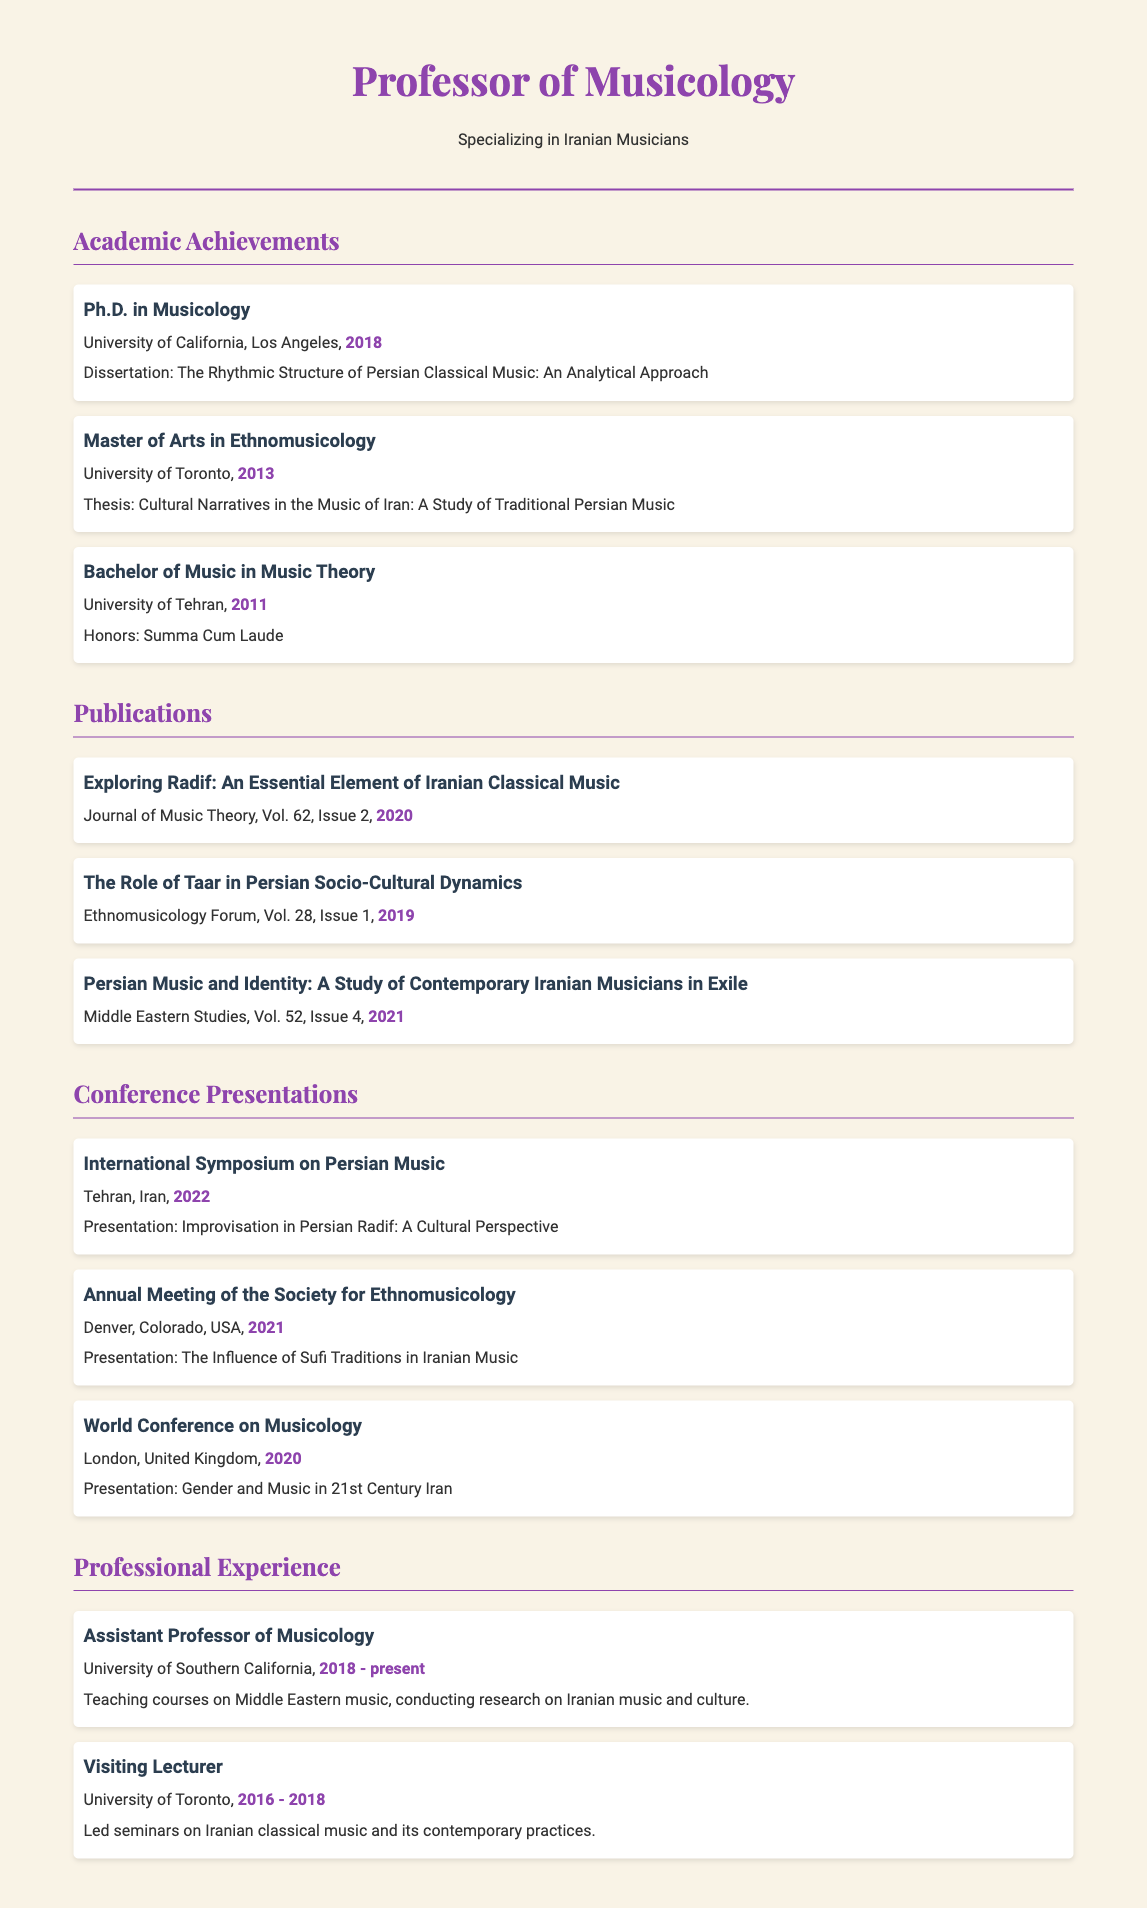What degree did the professor earn in 2018? The document states that the professor earned a Ph.D. in Musicology in 2018.
Answer: Ph.D. in Musicology What is the title of the dissertation? The dissertation title is mentioned in the academic achievements section.
Answer: The Rhythmic Structure of Persian Classical Music: An Analytical Approach Which journal published the article on Radif? The publication section specifies the journal where the article was published.
Answer: Journal of Music Theory In what year was the conference presentation on Sufi Traditions conducted? The year is found in the conference presentations section.
Answer: 2021 What is the academic position held by the professor at the University of Southern California? The professional experience section indicates the position held at that university.
Answer: Assistant Professor of Musicology Which university did the professor attend for their Master of Arts degree? The academic achievements section reveals the university for the Master's degree.
Answer: University of Toronto How many years did the professor serve as a visiting lecturer at the University of Toronto? The duration of their service is mentioned in the professional experience section.
Answer: 2 years What was the focus of the thesis during the Master's program? The thesis topic is described in the academic achievements section under the Master's degree.
Answer: Cultural Narratives in the Music of Iran: A Study of Traditional Persian Music 